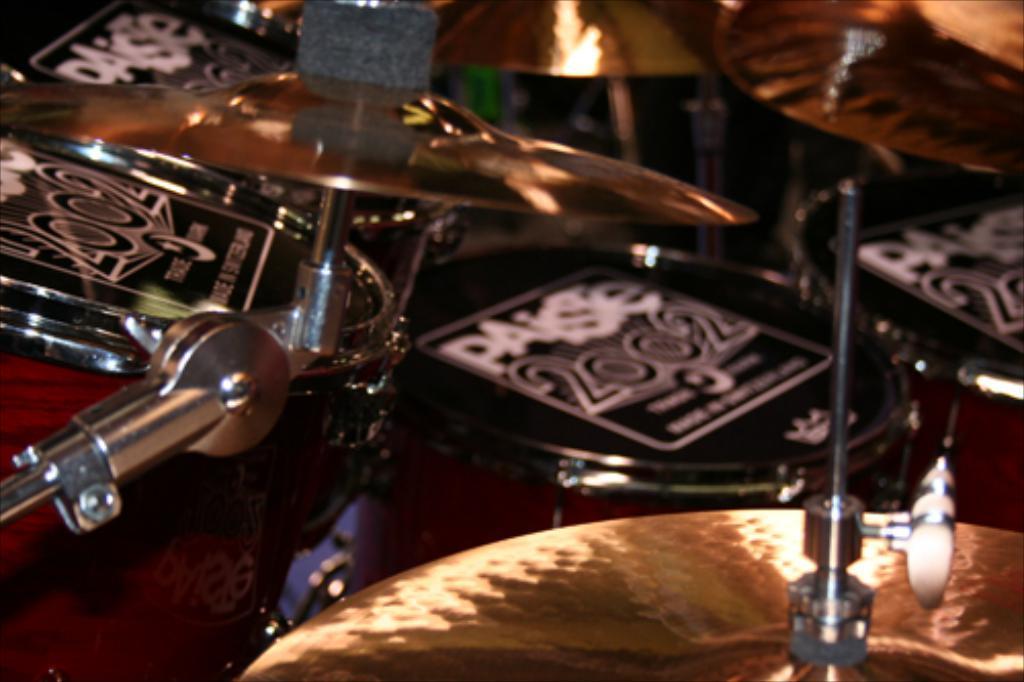Can you describe this image briefly? In this image I can see few musical instruments which are black, red and gold in color and I can see few rows which are silver in color. 